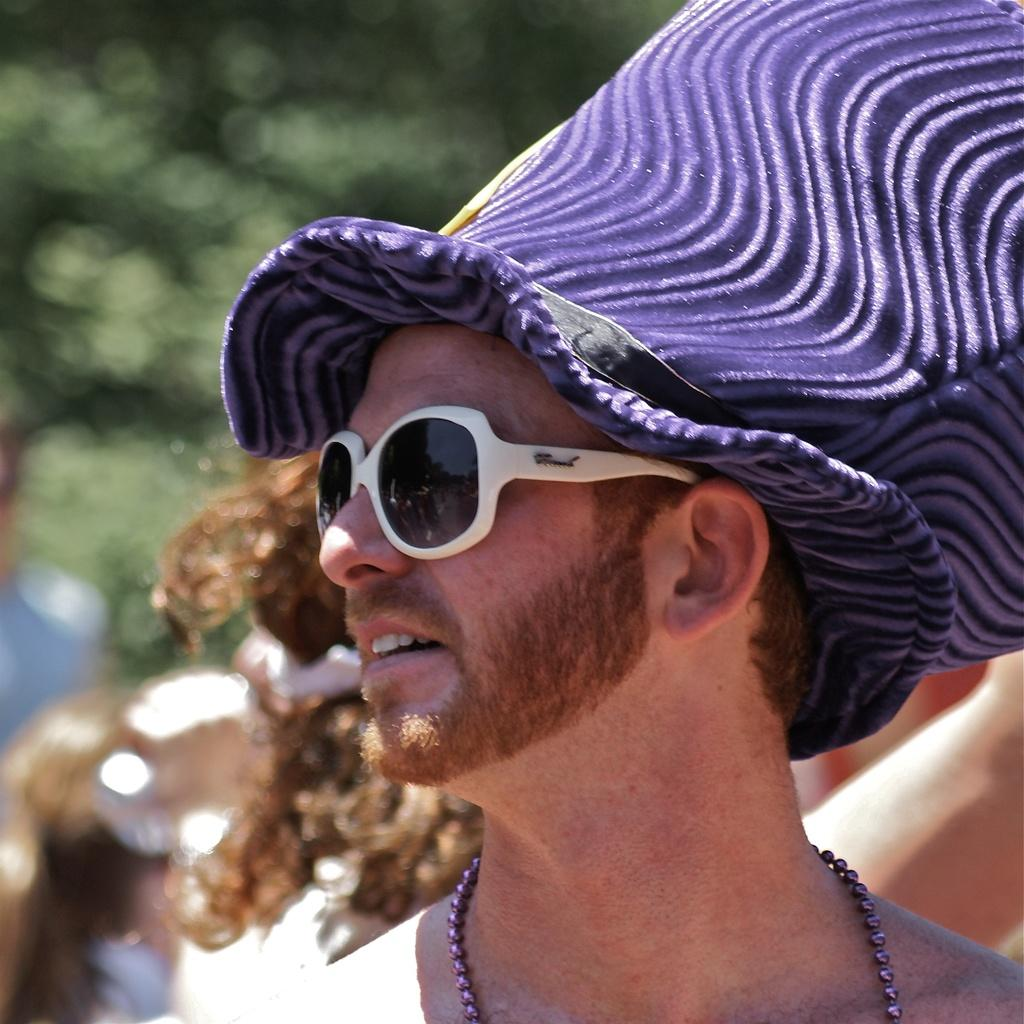What can be seen in the image? There is a person in the image. Can you describe the person's attire? The person is wearing white-colored goggles and a purple-colored hat. Are there any other people visible in the image? Yes, there are other persons in the background of the image. What can be seen in the background of the image? There are trees in the background of the image, which appear blurry. What type of canvas is being used by the person in the image? There is no canvas present in the image; the person is wearing a hat and goggles. What kind of wrench is being used by the person in the image? There is no wrench present in the image; the person is wearing goggles and a hat. 